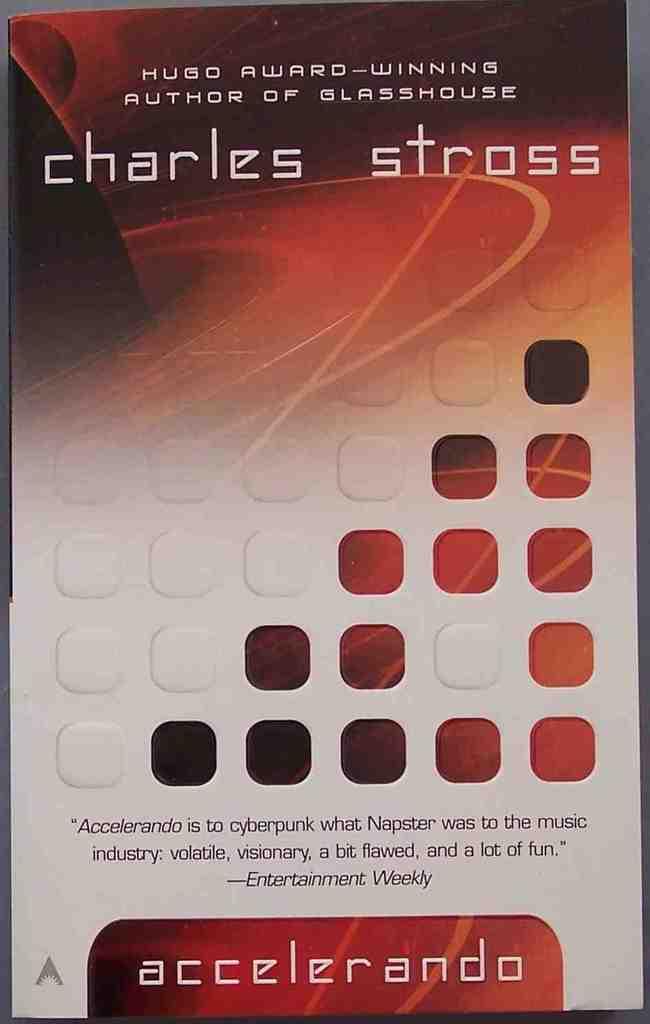What is the authors name?
Offer a very short reply. Charles stross. Whos name is written on the book cover?
Your answer should be very brief. Charles stross. 